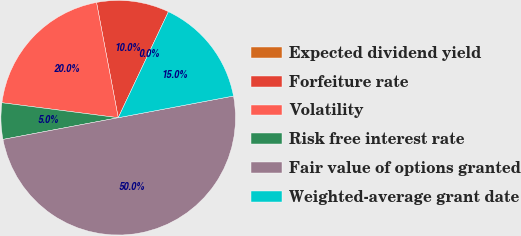<chart> <loc_0><loc_0><loc_500><loc_500><pie_chart><fcel>Expected dividend yield<fcel>Forfeiture rate<fcel>Volatility<fcel>Risk free interest rate<fcel>Fair value of options granted<fcel>Weighted-average grant date<nl><fcel>0.0%<fcel>10.0%<fcel>20.0%<fcel>5.0%<fcel>50.0%<fcel>15.0%<nl></chart> 